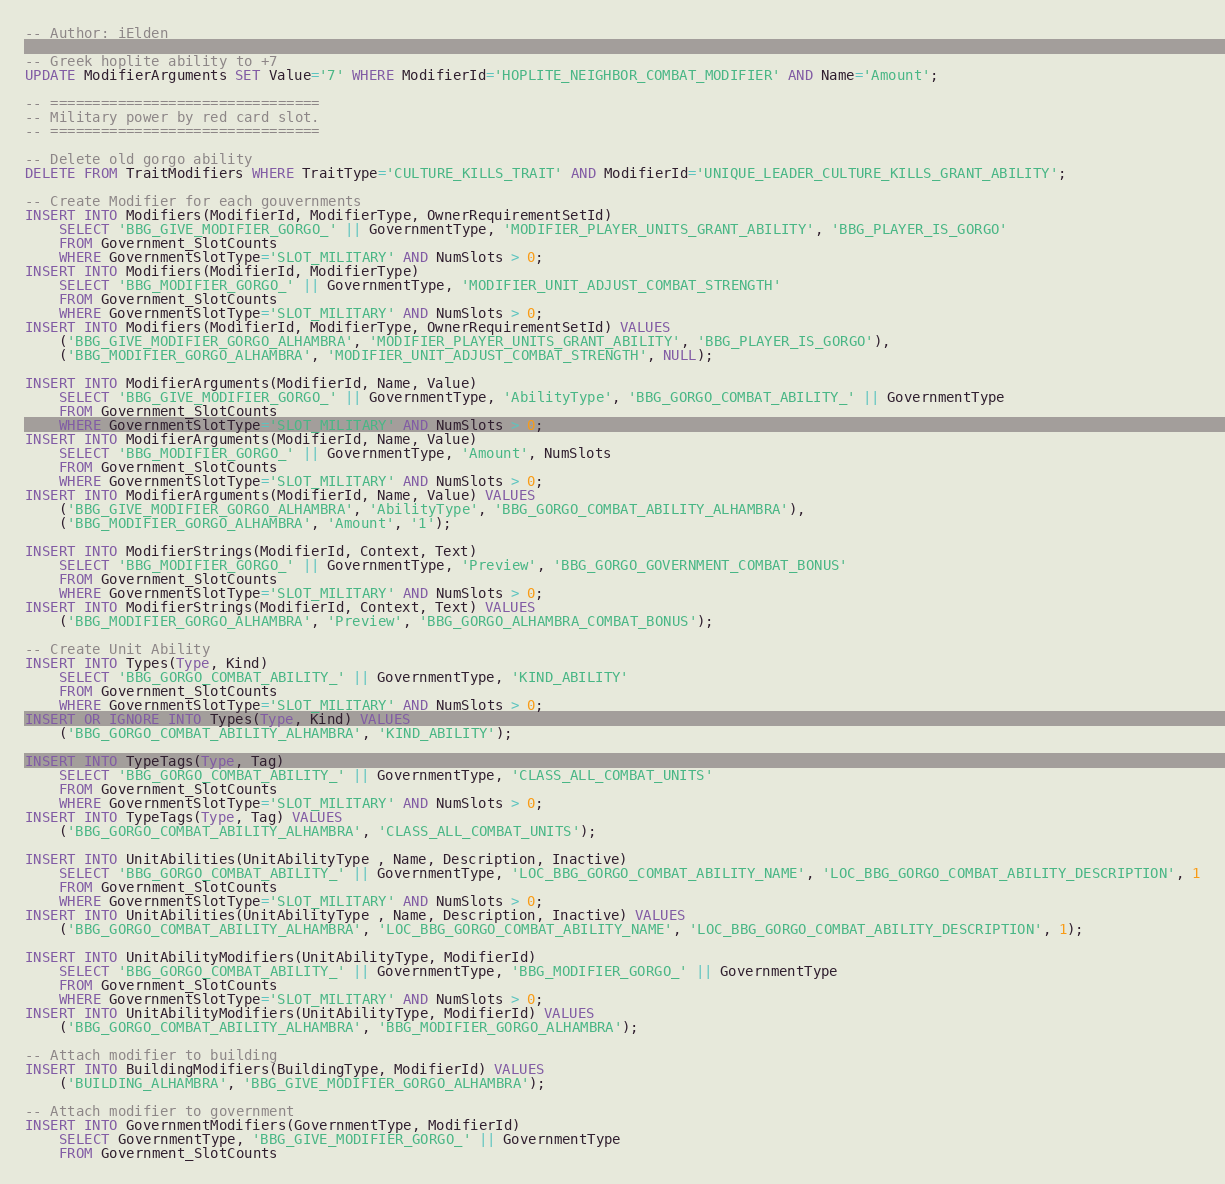Convert code to text. <code><loc_0><loc_0><loc_500><loc_500><_SQL_>-- Author: iElden

-- Greek hoplite ability to +7
UPDATE ModifierArguments SET Value='7' WHERE ModifierId='HOPLITE_NEIGHBOR_COMBAT_MODIFIER' AND Name='Amount';

-- ================================
-- Military power by red card slot.
-- ================================

-- Delete old gorgo ability
DELETE FROM TraitModifiers WHERE TraitType='CULTURE_KILLS_TRAIT' AND ModifierId='UNIQUE_LEADER_CULTURE_KILLS_GRANT_ABILITY';

-- Create Modifier for each gouvernments
INSERT INTO Modifiers(ModifierId, ModifierType, OwnerRequirementSetId)
    SELECT 'BBG_GIVE_MODIFIER_GORGO_' || GovernmentType, 'MODIFIER_PLAYER_UNITS_GRANT_ABILITY', 'BBG_PLAYER_IS_GORGO'
    FROM Government_SlotCounts
    WHERE GovernmentSlotType='SLOT_MILITARY' AND NumSlots > 0;
INSERT INTO Modifiers(ModifierId, ModifierType)
    SELECT 'BBG_MODIFIER_GORGO_' || GovernmentType, 'MODIFIER_UNIT_ADJUST_COMBAT_STRENGTH'
    FROM Government_SlotCounts
    WHERE GovernmentSlotType='SLOT_MILITARY' AND NumSlots > 0;
INSERT INTO Modifiers(ModifierId, ModifierType, OwnerRequirementSetId) VALUES
    ('BBG_GIVE_MODIFIER_GORGO_ALHAMBRA', 'MODIFIER_PLAYER_UNITS_GRANT_ABILITY', 'BBG_PLAYER_IS_GORGO'),
    ('BBG_MODIFIER_GORGO_ALHAMBRA', 'MODIFIER_UNIT_ADJUST_COMBAT_STRENGTH', NULL);

INSERT INTO ModifierArguments(ModifierId, Name, Value)
    SELECT 'BBG_GIVE_MODIFIER_GORGO_' || GovernmentType, 'AbilityType', 'BBG_GORGO_COMBAT_ABILITY_' || GovernmentType
    FROM Government_SlotCounts
    WHERE GovernmentSlotType='SLOT_MILITARY' AND NumSlots > 0;
INSERT INTO ModifierArguments(ModifierId, Name, Value)
    SELECT 'BBG_MODIFIER_GORGO_' || GovernmentType, 'Amount', NumSlots
    FROM Government_SlotCounts
    WHERE GovernmentSlotType='SLOT_MILITARY' AND NumSlots > 0;
INSERT INTO ModifierArguments(ModifierId, Name, Value) VALUES
    ('BBG_GIVE_MODIFIER_GORGO_ALHAMBRA', 'AbilityType', 'BBG_GORGO_COMBAT_ABILITY_ALHAMBRA'),
    ('BBG_MODIFIER_GORGO_ALHAMBRA', 'Amount', '1');

INSERT INTO ModifierStrings(ModifierId, Context, Text)
    SELECT 'BBG_MODIFIER_GORGO_' || GovernmentType, 'Preview', 'BBG_GORGO_GOVERNMENT_COMBAT_BONUS'
    FROM Government_SlotCounts
    WHERE GovernmentSlotType='SLOT_MILITARY' AND NumSlots > 0;
INSERT INTO ModifierStrings(ModifierId, Context, Text) VALUES
    ('BBG_MODIFIER_GORGO_ALHAMBRA', 'Preview', 'BBG_GORGO_ALHAMBRA_COMBAT_BONUS');

-- Create Unit Ability
INSERT INTO Types(Type, Kind)
	SELECT 'BBG_GORGO_COMBAT_ABILITY_' || GovernmentType, 'KIND_ABILITY'
    FROM Government_SlotCounts
    WHERE GovernmentSlotType='SLOT_MILITARY' AND NumSlots > 0;
INSERT OR IGNORE INTO Types(Type, Kind) VALUES
    ('BBG_GORGO_COMBAT_ABILITY_ALHAMBRA', 'KIND_ABILITY');

INSERT INTO TypeTags(Type, Tag)
    SELECT 'BBG_GORGO_COMBAT_ABILITY_' || GovernmentType, 'CLASS_ALL_COMBAT_UNITS'
    FROM Government_SlotCounts
    WHERE GovernmentSlotType='SLOT_MILITARY' AND NumSlots > 0;
INSERT INTO TypeTags(Type, Tag) VALUES
    ('BBG_GORGO_COMBAT_ABILITY_ALHAMBRA', 'CLASS_ALL_COMBAT_UNITS');

INSERT INTO UnitAbilities(UnitAbilityType , Name, Description, Inactive)
	SELECT 'BBG_GORGO_COMBAT_ABILITY_' || GovernmentType, 'LOC_BBG_GORGO_COMBAT_ABILITY_NAME', 'LOC_BBG_GORGO_COMBAT_ABILITY_DESCRIPTION', 1
    FROM Government_SlotCounts
    WHERE GovernmentSlotType='SLOT_MILITARY' AND NumSlots > 0;
INSERT INTO UnitAbilities(UnitAbilityType , Name, Description, Inactive) VALUES
    ('BBG_GORGO_COMBAT_ABILITY_ALHAMBRA', 'LOC_BBG_GORGO_COMBAT_ABILITY_NAME', 'LOC_BBG_GORGO_COMBAT_ABILITY_DESCRIPTION', 1);

INSERT INTO UnitAbilityModifiers(UnitAbilityType, ModifierId)
    SELECT 'BBG_GORGO_COMBAT_ABILITY_' || GovernmentType, 'BBG_MODIFIER_GORGO_' || GovernmentType
    FROM Government_SlotCounts
    WHERE GovernmentSlotType='SLOT_MILITARY' AND NumSlots > 0;
INSERT INTO UnitAbilityModifiers(UnitAbilityType, ModifierId) VALUES
    ('BBG_GORGO_COMBAT_ABILITY_ALHAMBRA', 'BBG_MODIFIER_GORGO_ALHAMBRA');

-- Attach modifier to building
INSERT INTO BuildingModifiers(BuildingType, ModifierId) VALUES
    ('BUILDING_ALHAMBRA', 'BBG_GIVE_MODIFIER_GORGO_ALHAMBRA');

-- Attach modifier to government
INSERT INTO GovernmentModifiers(GovernmentType, ModifierId)
    SELECT GovernmentType, 'BBG_GIVE_MODIFIER_GORGO_' || GovernmentType
    FROM Government_SlotCounts</code> 